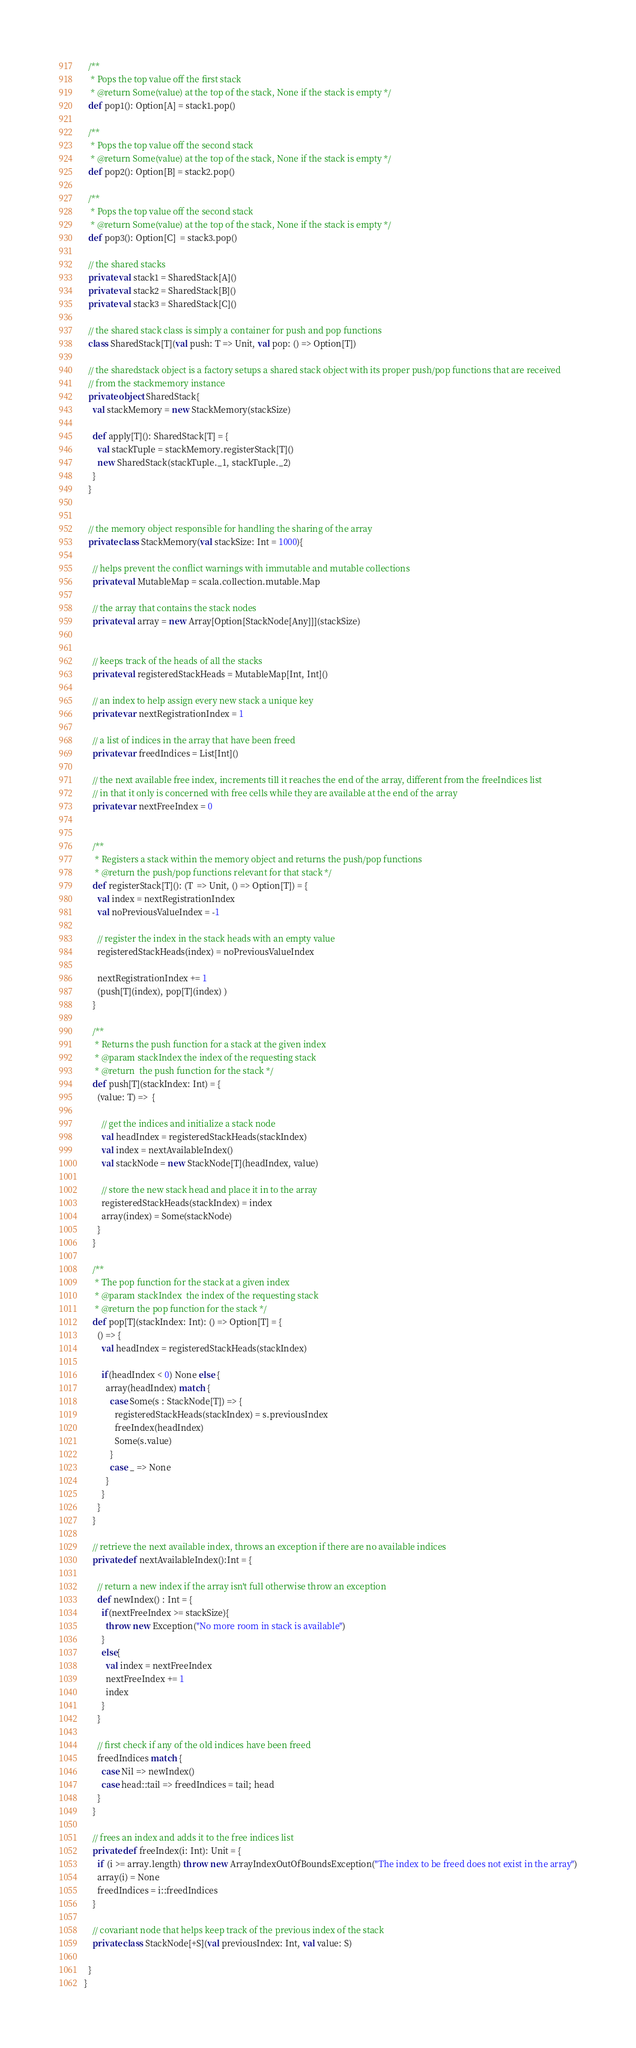<code> <loc_0><loc_0><loc_500><loc_500><_Scala_>
  /**
   * Pops the top value off the first stack
   * @return Some(value) at the top of the stack, None if the stack is empty */
  def pop1(): Option[A] = stack1.pop()

  /**
   * Pops the top value off the second stack
   * @return Some(value) at the top of the stack, None if the stack is empty */
  def pop2(): Option[B] = stack2.pop()

  /**
   * Pops the top value off the second stack
   * @return Some(value) at the top of the stack, None if the stack is empty */
  def pop3(): Option[C]  = stack3.pop()

  // the shared stacks
  private val stack1 = SharedStack[A]()
  private val stack2 = SharedStack[B]()
  private val stack3 = SharedStack[C]()

  // the shared stack class is simply a container for push and pop functions
  class SharedStack[T](val push: T => Unit, val pop: () => Option[T])

  // the sharedstack object is a factory setups a shared stack object with its proper push/pop functions that are received
  // from the stackmemory instance
  private object SharedStack{
    val stackMemory = new StackMemory(stackSize)

    def apply[T](): SharedStack[T] = {
      val stackTuple = stackMemory.registerStack[T]()
      new SharedStack(stackTuple._1, stackTuple._2)
    }
  }


  // the memory object responsible for handling the sharing of the array
  private class StackMemory(val stackSize: Int = 1000){

    // helps prevent the conflict warnings with immutable and mutable collections
    private val MutableMap = scala.collection.mutable.Map

    // the array that contains the stack nodes
    private val array = new Array[Option[StackNode[Any]]](stackSize)


    // keeps track of the heads of all the stacks
    private val registeredStackHeads = MutableMap[Int, Int]()

    // an index to help assign every new stack a unique key
    private var nextRegistrationIndex = 1

    // a list of indices in the array that have been freed
    private var freedIndices = List[Int]()

    // the next available free index, increments till it reaches the end of the array, different from the freeIndices list
    // in that it only is concerned with free cells while they are available at the end of the array
    private var nextFreeIndex = 0


    /**
     * Registers a stack within the memory object and returns the push/pop functions
     * @return the push/pop functions relevant for that stack */
    def registerStack[T](): (T  => Unit, () => Option[T]) = {
      val index = nextRegistrationIndex
      val noPreviousValueIndex = -1

      // register the index in the stack heads with an empty value
      registeredStackHeads(index) = noPreviousValueIndex

      nextRegistrationIndex += 1
      (push[T](index), pop[T](index) )
    }

    /**
     * Returns the push function for a stack at the given index
     * @param stackIndex the index of the requesting stack
     * @return  the push function for the stack */
    def push[T](stackIndex: Int) = {
      (value: T) =>  {

        // get the indices and initialize a stack node
        val headIndex = registeredStackHeads(stackIndex)
        val index = nextAvailableIndex()
        val stackNode = new StackNode[T](headIndex, value)

        // store the new stack head and place it in to the array
        registeredStackHeads(stackIndex) = index
        array(index) = Some(stackNode)
      }
    }

    /**
     * The pop function for the stack at a given index
     * @param stackIndex  the index of the requesting stack
     * @return the pop function for the stack */
    def pop[T](stackIndex: Int): () => Option[T] = {
      () => {
        val headIndex = registeredStackHeads(stackIndex)

        if(headIndex < 0) None else {
          array(headIndex) match {
            case Some(s : StackNode[T]) => {
              registeredStackHeads(stackIndex) = s.previousIndex
              freeIndex(headIndex)
              Some(s.value)
            }
            case _ => None
          }
        }
      }
    }

    // retrieve the next available index, throws an exception if there are no available indices
    private def nextAvailableIndex():Int = {

      // return a new index if the array isn't full otherwise throw an exception
      def newIndex() : Int = {
        if(nextFreeIndex >= stackSize){
          throw new Exception("No more room in stack is available")
        }
        else{
          val index = nextFreeIndex
          nextFreeIndex += 1
          index
        }
      }

      // first check if any of the old indices have been freed
      freedIndices match {
        case Nil => newIndex()
        case head::tail => freedIndices = tail; head
      }
    }

    // frees an index and adds it to the free indices list
    private def freeIndex(i: Int): Unit = {
      if (i >= array.length) throw new ArrayIndexOutOfBoundsException("The index to be freed does not exist in the array")
      array(i) = None
      freedIndices = i::freedIndices
    }

    // covariant node that helps keep track of the previous index of the stack
    private class StackNode[+S](val previousIndex: Int, val value: S)

  }
}
</code> 